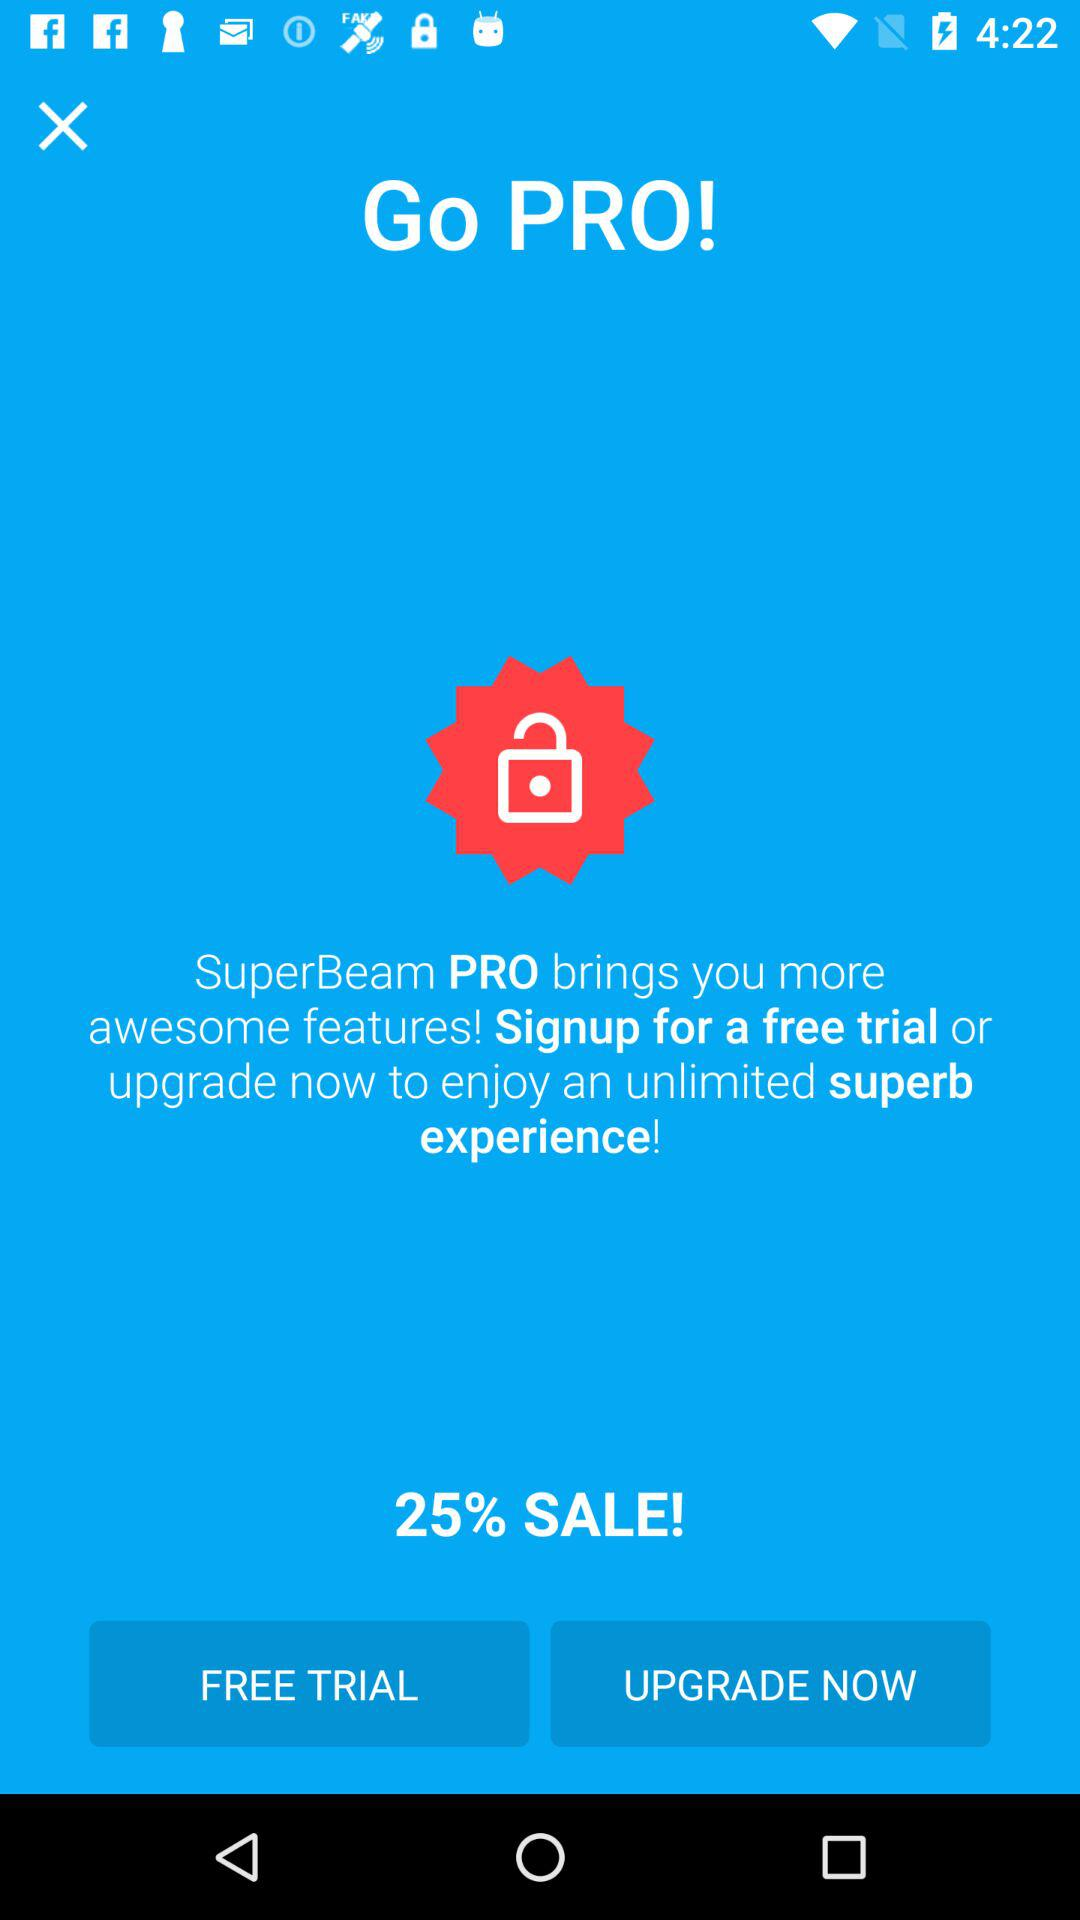What to do for sign up?
When the provided information is insufficient, respond with <no answer>. <no answer> 